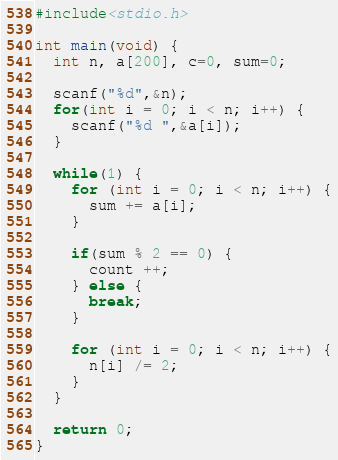<code> <loc_0><loc_0><loc_500><loc_500><_C_>#include<stdio.h>

int main(void) {
  int n, a[200], c=0, sum=0;
  
  scanf("%d",&n);
  for(int i = 0; i < n; i++) {
    scanf("%d ",&a[i]);
  }
  
  while(1) {
    for (int i = 0; i < n; i++) {
      sum += a[i];
    }
    
    if(sum % 2 == 0) {
      count ++;
    } else {
      break;
    }
    
    for (int i = 0; i < n; i++) {
      n[i] /= 2;
    }
  }
  
  return 0;
}</code> 